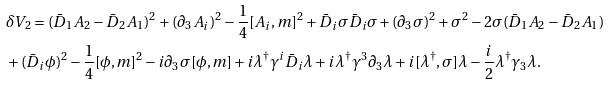Convert formula to latex. <formula><loc_0><loc_0><loc_500><loc_500>& \delta V _ { 2 } = ( \bar { D } _ { 1 } A _ { 2 } - \bar { D } _ { 2 } A _ { 1 } ) ^ { 2 } + ( \partial _ { 3 } A _ { i } ) ^ { 2 } - \frac { 1 } { 4 } [ A _ { i } , m ] ^ { 2 } + \bar { D } _ { i } \sigma \bar { D } _ { i } \sigma + ( \partial _ { 3 } \sigma ) ^ { 2 } + \sigma ^ { 2 } - 2 \sigma ( \bar { D } _ { 1 } A _ { 2 } - \bar { D } _ { 2 } A _ { 1 } ) \\ & + ( \bar { D } _ { i } \phi ) ^ { 2 } - \frac { 1 } { 4 } [ \phi , m ] ^ { 2 } - i \partial _ { 3 } \sigma [ \phi , m ] + i \lambda ^ { \dagger } \gamma ^ { i } \bar { D } _ { i } \lambda + i \lambda ^ { \dagger } \gamma ^ { 3 } \partial _ { 3 } \lambda + i [ \lambda ^ { \dagger } , \sigma ] \lambda - \frac { i } 2 \lambda ^ { \dagger } \gamma _ { 3 } \lambda .</formula> 